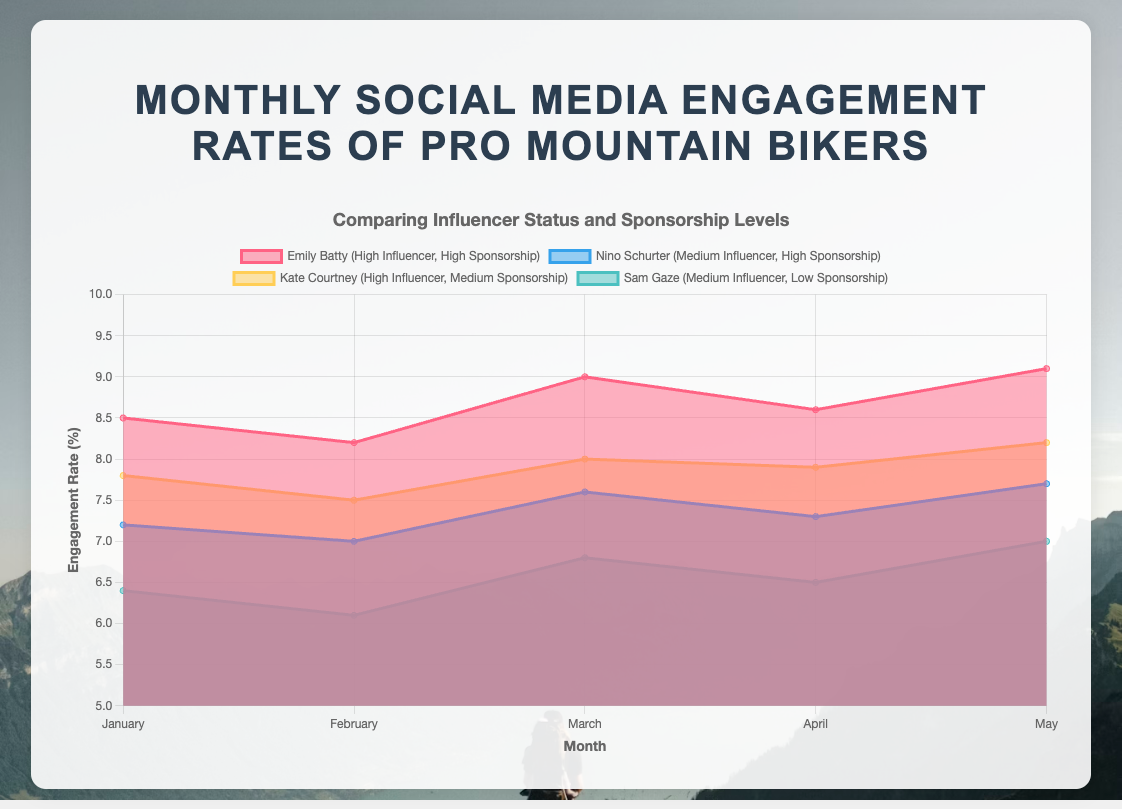What month did Emily Batty have the highest engagement rate? Look at the line for Emily Batty in the chart and find the highest point. Her highest engagement rate was in May.
Answer: May What is the overall trend in engagement rate for Nino Schurter from January to May? Observe Nino Schurter's line on the chart. It's generally increasing with some fluctuations.
Answer: Generally increasing How does Kate Courtney's engagement rate in April compare to her rate in May? Compare the height of Kate Courtney's line between April and May. It increased from April to May.
Answer: Increased Which rider showed the most consistent engagement rate across all months? Look at the smoothness of the lines for each rider. Emily Batty's line shows small fluctuations.
Answer: Emily Batty Which month had the lowest engagement rate for Sam Gaze? Find the lowest point on the line representing Sam Gaze. The lowest point is in February.
Answer: February What is the average engagement rate for all riders in March? Sum the engagement rates for March and divide by the number of values. (9.0 + 7.6 + 8.0 + 6.8) / 4 = 31.4 / 4
Answer: 7.85 How does the engagement rate of high influencers with medium sponsorships (Kate Courtney) generally compare to medium influencers with high sponsorships (Nino Schurter)? Compare the lines of Kate Courtney and Nino Schurter. Kate Courtney generally has higher engagement rates than Nino Schurter.
Answer: Higher Across all months, which pair of riders showed the most similar patterns in engagement rates? Look at pairs of lines that move similarly. Emily Batty and Kate Courtney have similar ups and downs in their engagement rates.
Answer: Emily Batty and Kate Courtney What is the range of engagement rate values for all riders in January? Identify the maximum and minimum rates for January. The values are 8.5 and 6.4, so the range is 8.5 - 6.4.
Answer: 2.1 During which month did Emily Batty see a slight drop in her engagement rate before rebounding in the following month? Look at the trend of Emily Batty's engagement rate line. There is a slight drop from January to February and then a rebound in March.
Answer: February 